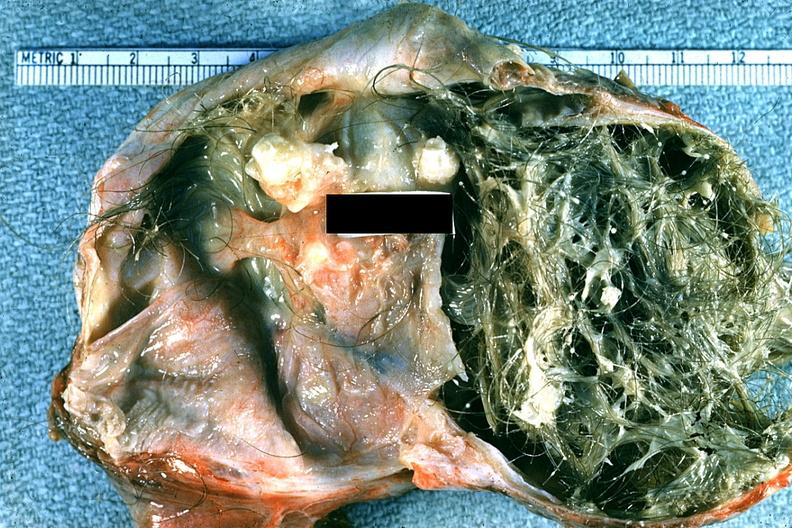what is present?
Answer the question using a single word or phrase. Benign cystic teratoma 